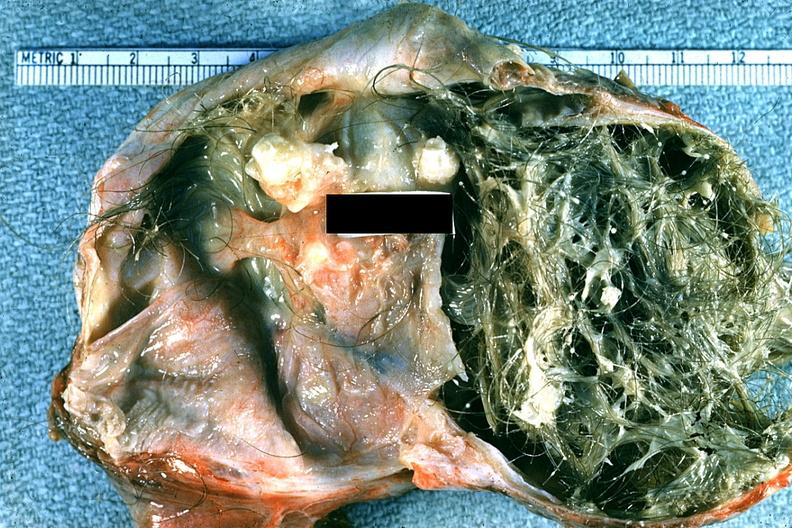what is present?
Answer the question using a single word or phrase. Benign cystic teratoma 